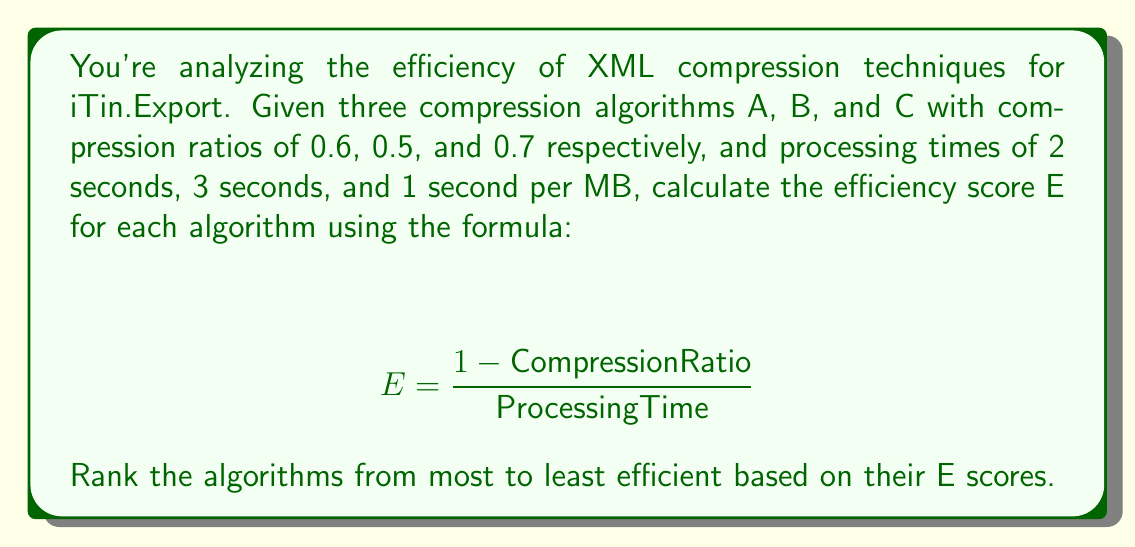Help me with this question. Let's calculate the efficiency score E for each algorithm:

1. Algorithm A:
   $$ E_A = \frac{1 - 0.6}{2} = \frac{0.4}{2} = 0.2 $$

2. Algorithm B:
   $$ E_B = \frac{1 - 0.5}{3} = \frac{0.5}{3} \approx 0.1667 $$

3. Algorithm C:
   $$ E_C = \frac{1 - 0.7}{1} = \frac{0.3}{1} = 0.3 $$

Now, let's rank the algorithms based on their E scores from highest to lowest:

1. Algorithm C: E = 0.3
2. Algorithm A: E = 0.2
3. Algorithm B: E ≈ 0.1667

Therefore, the ranking from most to least efficient is: C, A, B.
Answer: C, A, B 